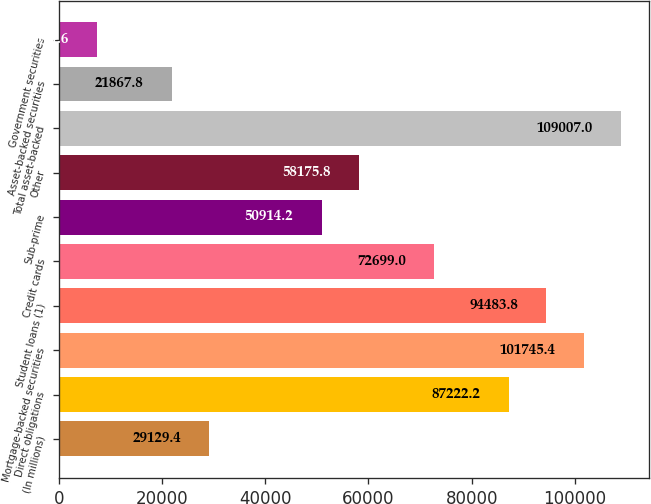Convert chart to OTSL. <chart><loc_0><loc_0><loc_500><loc_500><bar_chart><fcel>(In millions)<fcel>Direct obligations<fcel>Mortgage-backed securities<fcel>Student loans (1)<fcel>Credit cards<fcel>Sub-prime<fcel>Other<fcel>Total asset-backed<fcel>Asset-backed securities<fcel>Government securities<nl><fcel>29129.4<fcel>87222.2<fcel>101745<fcel>94483.8<fcel>72699<fcel>50914.2<fcel>58175.8<fcel>109007<fcel>21867.8<fcel>7344.6<nl></chart> 